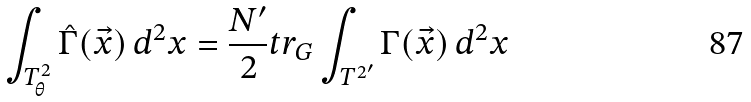Convert formula to latex. <formula><loc_0><loc_0><loc_500><loc_500>\int _ { T _ { \theta } ^ { 2 } } \hat { \Gamma } ( \vec { x } ) \, d ^ { 2 } x = \frac { N ^ { \prime } } { 2 } t r _ { G } \int _ { { T ^ { 2 } } ^ { \prime } } \Gamma ( \vec { x } ) \, d ^ { 2 } x</formula> 